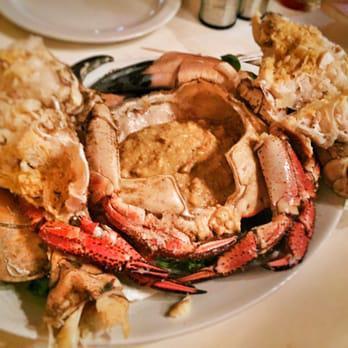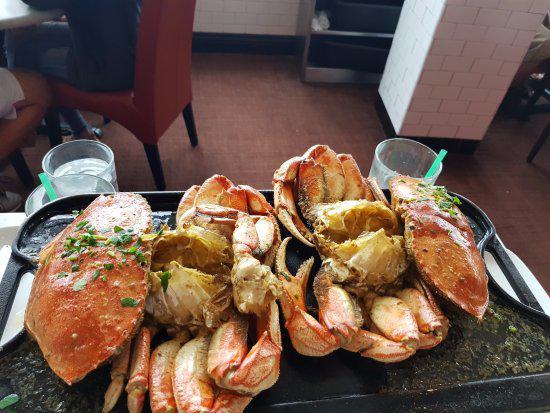The first image is the image on the left, the second image is the image on the right. For the images shown, is this caption "Each image contains exactly one round white plate that contains crab [and no other plates containing crab]." true? Answer yes or no. No. 